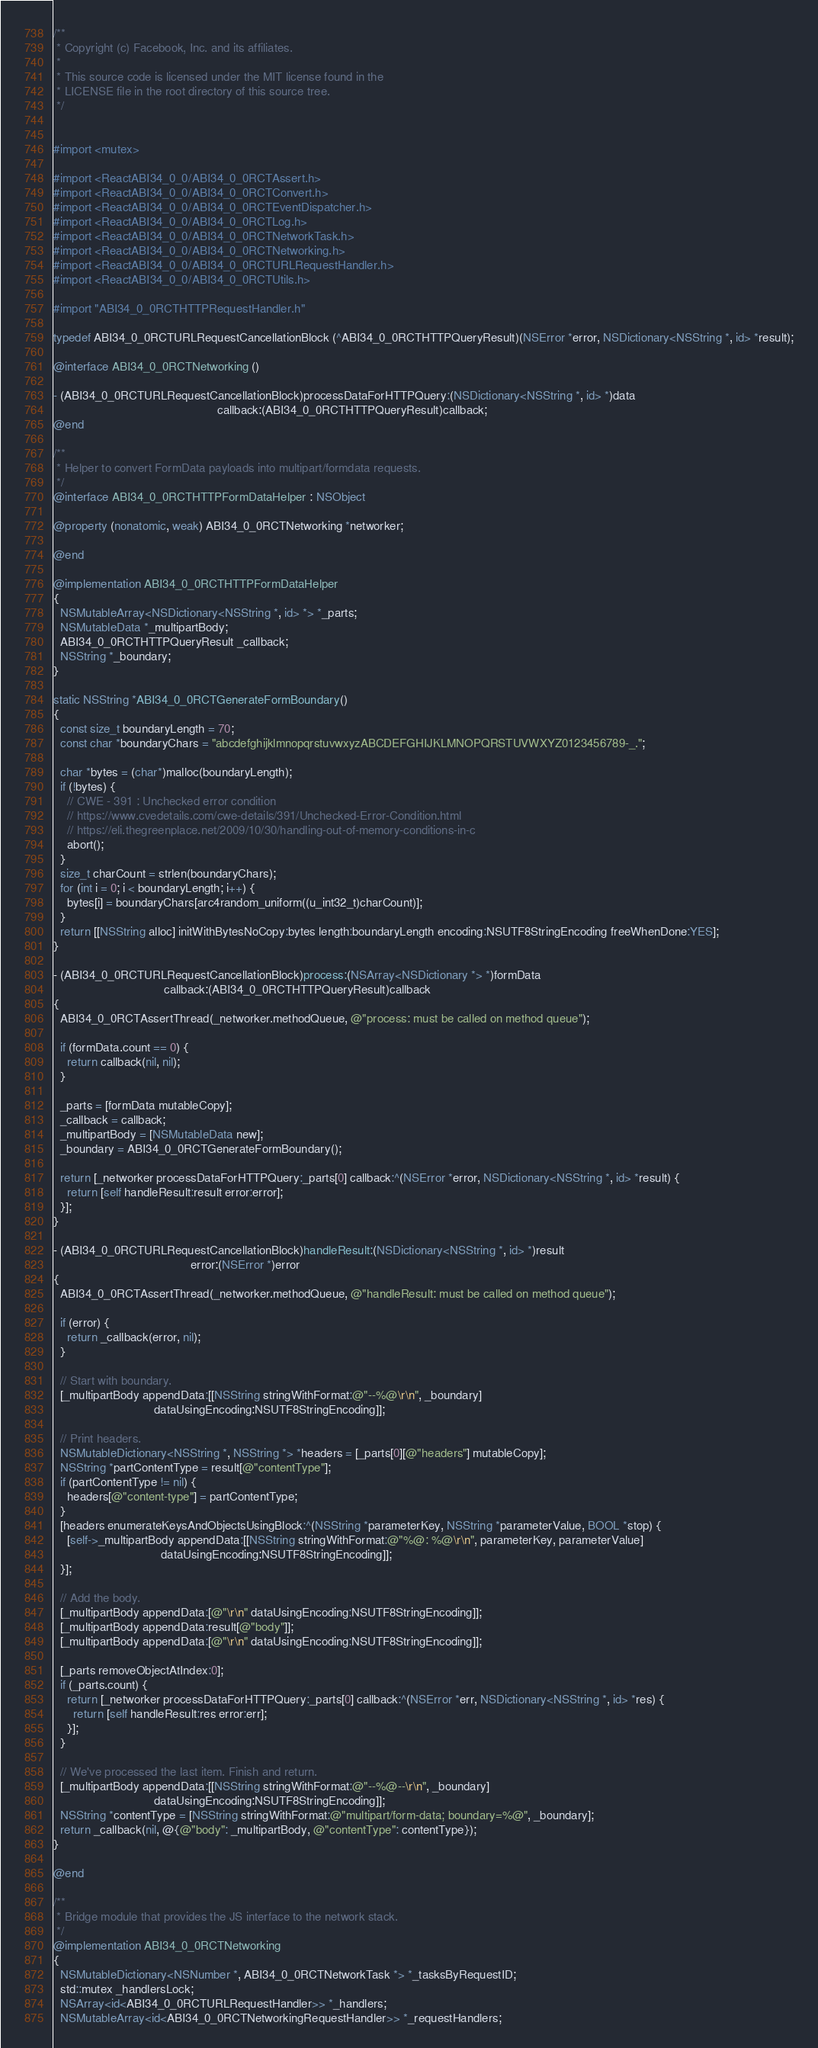Convert code to text. <code><loc_0><loc_0><loc_500><loc_500><_ObjectiveC_>/**
 * Copyright (c) Facebook, Inc. and its affiliates.
 *
 * This source code is licensed under the MIT license found in the
 * LICENSE file in the root directory of this source tree.
 */


#import <mutex>

#import <ReactABI34_0_0/ABI34_0_0RCTAssert.h>
#import <ReactABI34_0_0/ABI34_0_0RCTConvert.h>
#import <ReactABI34_0_0/ABI34_0_0RCTEventDispatcher.h>
#import <ReactABI34_0_0/ABI34_0_0RCTLog.h>
#import <ReactABI34_0_0/ABI34_0_0RCTNetworkTask.h>
#import <ReactABI34_0_0/ABI34_0_0RCTNetworking.h>
#import <ReactABI34_0_0/ABI34_0_0RCTURLRequestHandler.h>
#import <ReactABI34_0_0/ABI34_0_0RCTUtils.h>

#import "ABI34_0_0RCTHTTPRequestHandler.h"

typedef ABI34_0_0RCTURLRequestCancellationBlock (^ABI34_0_0RCTHTTPQueryResult)(NSError *error, NSDictionary<NSString *, id> *result);

@interface ABI34_0_0RCTNetworking ()

- (ABI34_0_0RCTURLRequestCancellationBlock)processDataForHTTPQuery:(NSDictionary<NSString *, id> *)data
                                                 callback:(ABI34_0_0RCTHTTPQueryResult)callback;
@end

/**
 * Helper to convert FormData payloads into multipart/formdata requests.
 */
@interface ABI34_0_0RCTHTTPFormDataHelper : NSObject

@property (nonatomic, weak) ABI34_0_0RCTNetworking *networker;

@end

@implementation ABI34_0_0RCTHTTPFormDataHelper
{
  NSMutableArray<NSDictionary<NSString *, id> *> *_parts;
  NSMutableData *_multipartBody;
  ABI34_0_0RCTHTTPQueryResult _callback;
  NSString *_boundary;
}

static NSString *ABI34_0_0RCTGenerateFormBoundary()
{
  const size_t boundaryLength = 70;
  const char *boundaryChars = "abcdefghijklmnopqrstuvwxyzABCDEFGHIJKLMNOPQRSTUVWXYZ0123456789-_.";

  char *bytes = (char*)malloc(boundaryLength);
  if (!bytes) {
    // CWE - 391 : Unchecked error condition
    // https://www.cvedetails.com/cwe-details/391/Unchecked-Error-Condition.html
    // https://eli.thegreenplace.net/2009/10/30/handling-out-of-memory-conditions-in-c
    abort();
  }
  size_t charCount = strlen(boundaryChars);
  for (int i = 0; i < boundaryLength; i++) {
    bytes[i] = boundaryChars[arc4random_uniform((u_int32_t)charCount)];
  }
  return [[NSString alloc] initWithBytesNoCopy:bytes length:boundaryLength encoding:NSUTF8StringEncoding freeWhenDone:YES];
}

- (ABI34_0_0RCTURLRequestCancellationBlock)process:(NSArray<NSDictionary *> *)formData
                                 callback:(ABI34_0_0RCTHTTPQueryResult)callback
{
  ABI34_0_0RCTAssertThread(_networker.methodQueue, @"process: must be called on method queue");

  if (formData.count == 0) {
    return callback(nil, nil);
  }

  _parts = [formData mutableCopy];
  _callback = callback;
  _multipartBody = [NSMutableData new];
  _boundary = ABI34_0_0RCTGenerateFormBoundary();

  return [_networker processDataForHTTPQuery:_parts[0] callback:^(NSError *error, NSDictionary<NSString *, id> *result) {
    return [self handleResult:result error:error];
  }];
}

- (ABI34_0_0RCTURLRequestCancellationBlock)handleResult:(NSDictionary<NSString *, id> *)result
                                         error:(NSError *)error
{
  ABI34_0_0RCTAssertThread(_networker.methodQueue, @"handleResult: must be called on method queue");

  if (error) {
    return _callback(error, nil);
  }

  // Start with boundary.
  [_multipartBody appendData:[[NSString stringWithFormat:@"--%@\r\n", _boundary]
                              dataUsingEncoding:NSUTF8StringEncoding]];

  // Print headers.
  NSMutableDictionary<NSString *, NSString *> *headers = [_parts[0][@"headers"] mutableCopy];
  NSString *partContentType = result[@"contentType"];
  if (partContentType != nil) {
    headers[@"content-type"] = partContentType;
  }
  [headers enumerateKeysAndObjectsUsingBlock:^(NSString *parameterKey, NSString *parameterValue, BOOL *stop) {
    [self->_multipartBody appendData:[[NSString stringWithFormat:@"%@: %@\r\n", parameterKey, parameterValue]
                                dataUsingEncoding:NSUTF8StringEncoding]];
  }];

  // Add the body.
  [_multipartBody appendData:[@"\r\n" dataUsingEncoding:NSUTF8StringEncoding]];
  [_multipartBody appendData:result[@"body"]];
  [_multipartBody appendData:[@"\r\n" dataUsingEncoding:NSUTF8StringEncoding]];

  [_parts removeObjectAtIndex:0];
  if (_parts.count) {
    return [_networker processDataForHTTPQuery:_parts[0] callback:^(NSError *err, NSDictionary<NSString *, id> *res) {
      return [self handleResult:res error:err];
    }];
  }

  // We've processed the last item. Finish and return.
  [_multipartBody appendData:[[NSString stringWithFormat:@"--%@--\r\n", _boundary]
                              dataUsingEncoding:NSUTF8StringEncoding]];
  NSString *contentType = [NSString stringWithFormat:@"multipart/form-data; boundary=%@", _boundary];
  return _callback(nil, @{@"body": _multipartBody, @"contentType": contentType});
}

@end

/**
 * Bridge module that provides the JS interface to the network stack.
 */
@implementation ABI34_0_0RCTNetworking
{
  NSMutableDictionary<NSNumber *, ABI34_0_0RCTNetworkTask *> *_tasksByRequestID;
  std::mutex _handlersLock;
  NSArray<id<ABI34_0_0RCTURLRequestHandler>> *_handlers;
  NSMutableArray<id<ABI34_0_0RCTNetworkingRequestHandler>> *_requestHandlers;</code> 